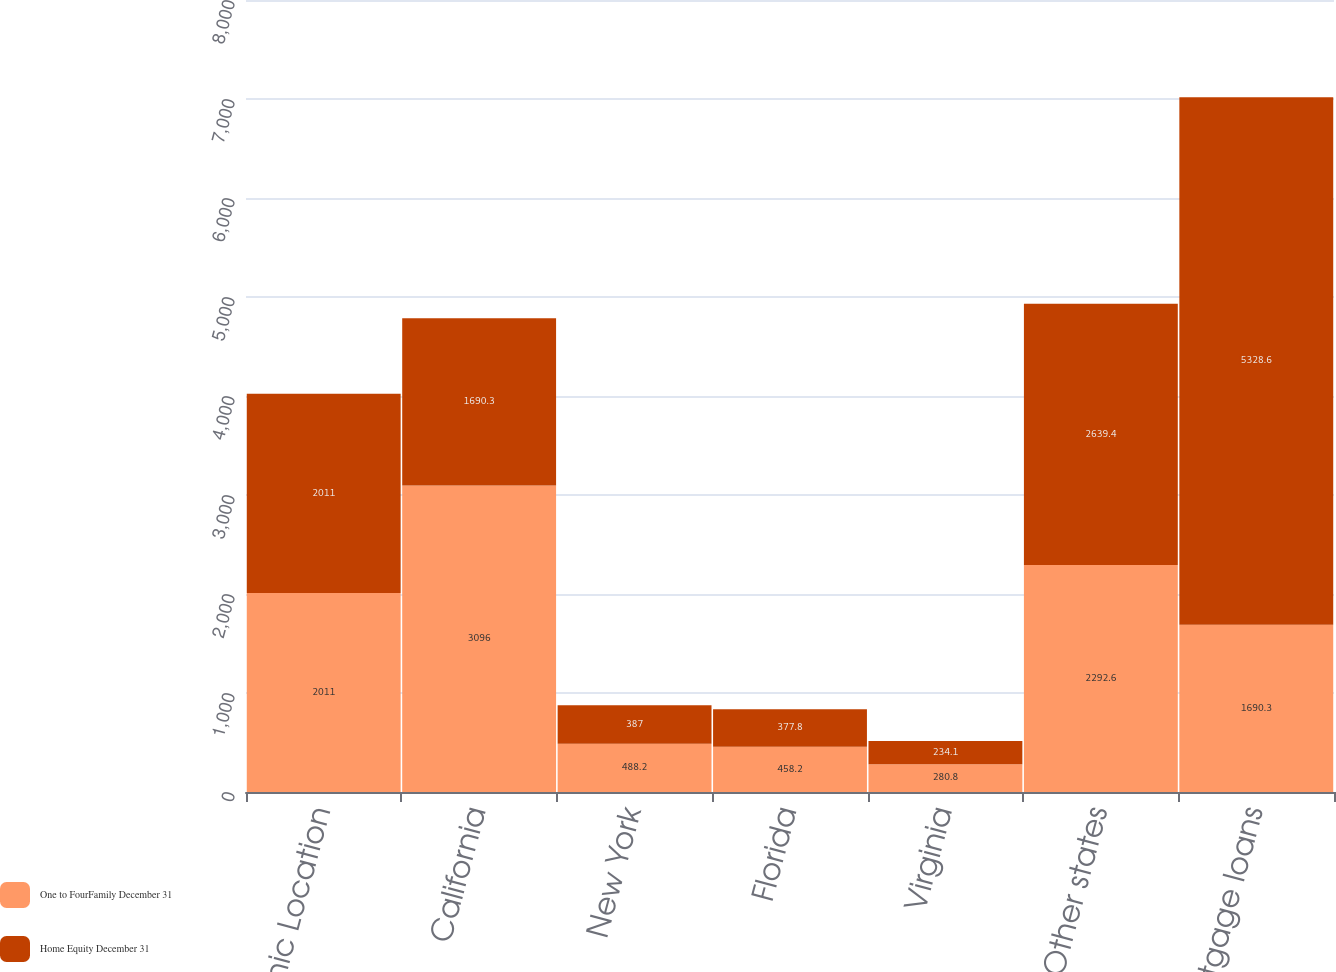<chart> <loc_0><loc_0><loc_500><loc_500><stacked_bar_chart><ecel><fcel>Geographic Location<fcel>California<fcel>New York<fcel>Florida<fcel>Virginia<fcel>Other states<fcel>Total mortgage loans<nl><fcel>One to FourFamily December 31<fcel>2011<fcel>3096<fcel>488.2<fcel>458.2<fcel>280.8<fcel>2292.6<fcel>1690.3<nl><fcel>Home Equity December 31<fcel>2011<fcel>1690.3<fcel>387<fcel>377.8<fcel>234.1<fcel>2639.4<fcel>5328.6<nl></chart> 